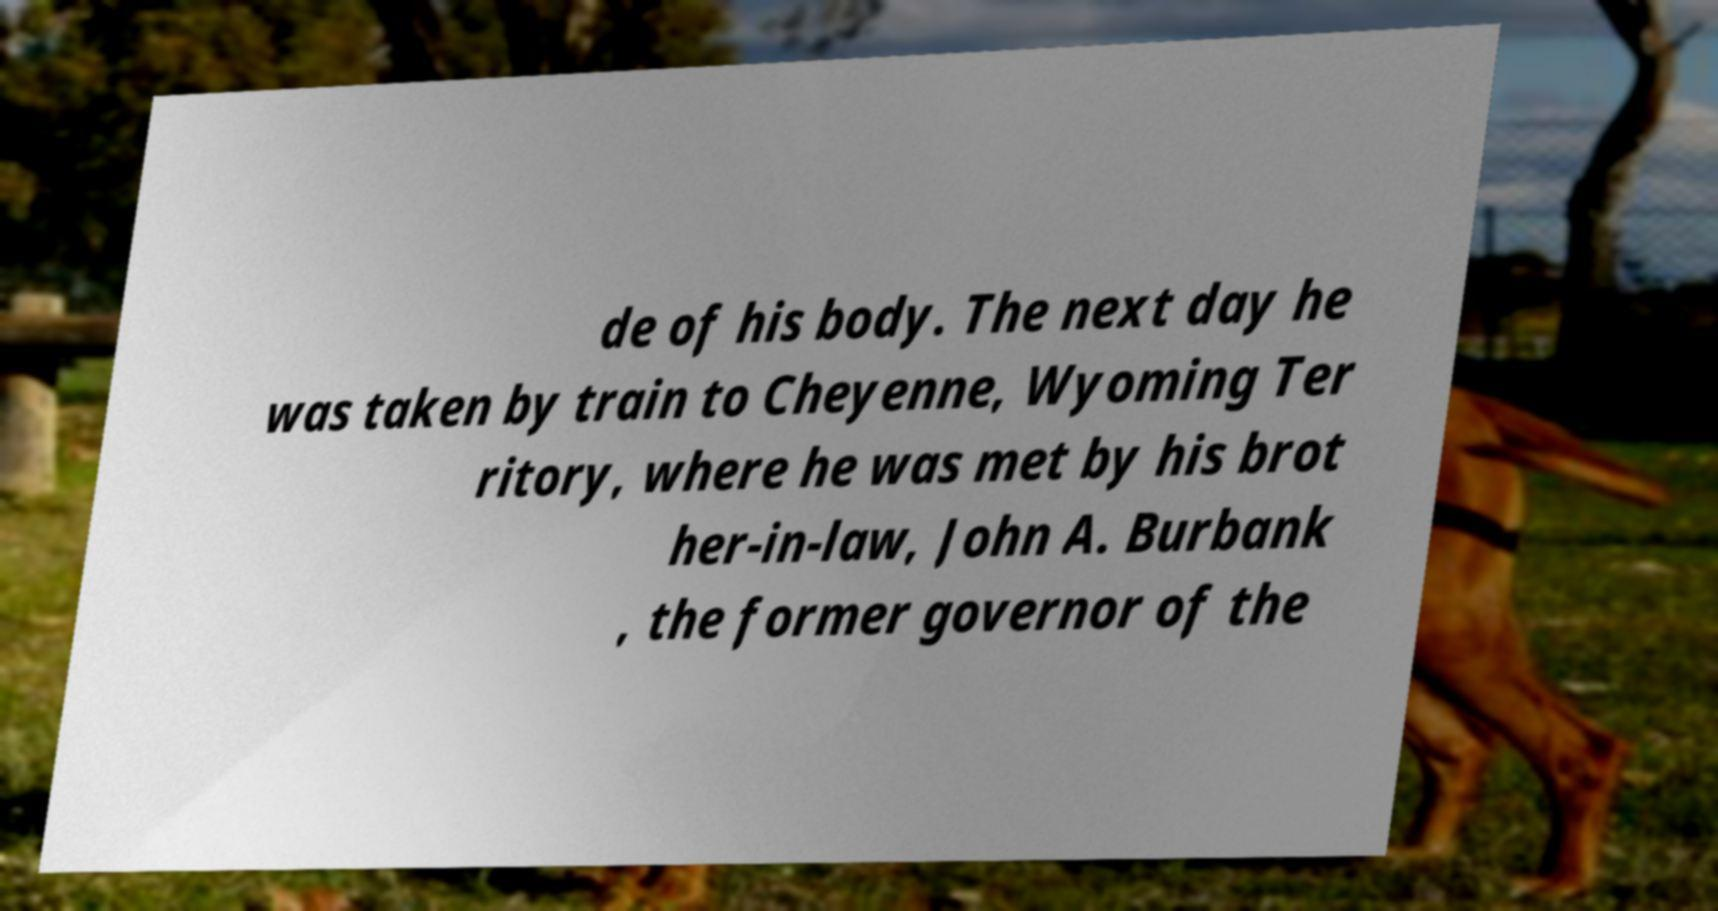Can you read and provide the text displayed in the image?This photo seems to have some interesting text. Can you extract and type it out for me? de of his body. The next day he was taken by train to Cheyenne, Wyoming Ter ritory, where he was met by his brot her-in-law, John A. Burbank , the former governor of the 